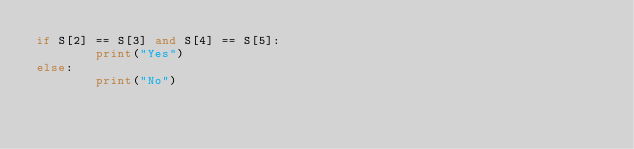Convert code to text. <code><loc_0><loc_0><loc_500><loc_500><_Python_>if S[2] == S[3] and S[4] == S[5]:
        print("Yes")
else:
        print("No")</code> 